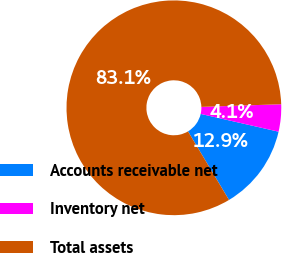Convert chart. <chart><loc_0><loc_0><loc_500><loc_500><pie_chart><fcel>Accounts receivable net<fcel>Inventory net<fcel>Total assets<nl><fcel>12.85%<fcel>4.1%<fcel>83.05%<nl></chart> 